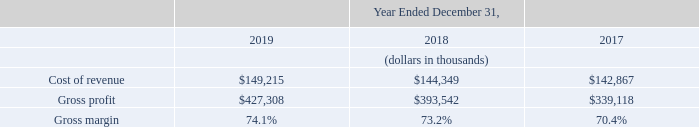Cost of Revenue, Gross Profit, and Gross Margin
Cost of revenue increased $4.9 million, or 3%, in 2019 as compared to 2018. The increase in cost of revenue was primarily due to $12.1 million in increased personnel expenses, stock-based compensation, and overhead costs, $3.9 million in increased content costs, $3.6 million in increased amortization of acquired intangible assets, and $1.6 million in increased capitalized software amortization. These increased costs were partially offset by $16.4 million in decreased external implementation professional service costs. These costs were incurred to service our existing customers and support our continued growth. The improvement in gross margin was primarily due to a higher mix of subscription revenue, which carries a higher gross margin.
Cost of revenue increased $1.5 million, or 1%, in 2018 as compared to 2017. The increase in cost of revenue was primarily due to $6.0 million in increased capitalized software amortization and $4.5 million in increased content costs. These increased costs were partially offset by $6.6 million in decreased amortization of acquired intangible assets and $2.9 million in external implementation service costs. These costs were incurred to service our existing customers and support our continued growth. The improvement in gross margin was primarily due to a higher mix of subscription revenue, which carries a higher gross margin.
Why did gross margin improve between 2018 and 2019? The improvement in gross margin was primarily due to a higher mix of subscription revenue, which carries a higher gross margin. What was the cost of revenue in 2019?
Answer scale should be: thousand. $149,215. What was the gross profit in 2019?
Answer scale should be: thousand. $427,308. What was the change in cost of revenue between 2017 and 2018?
Answer scale should be: thousand. ($144,349-$142,867)
Answer: 1482. What was the percentage change in gross profit between 2018 and 2019?
Answer scale should be: percent. ($427,308-$393,542)/$393,542
Answer: 8.58. What was the change in gross margin between 2018 and 2019?
Answer scale should be: percent. (74.1%-73.2%)
Answer: 0.9. 